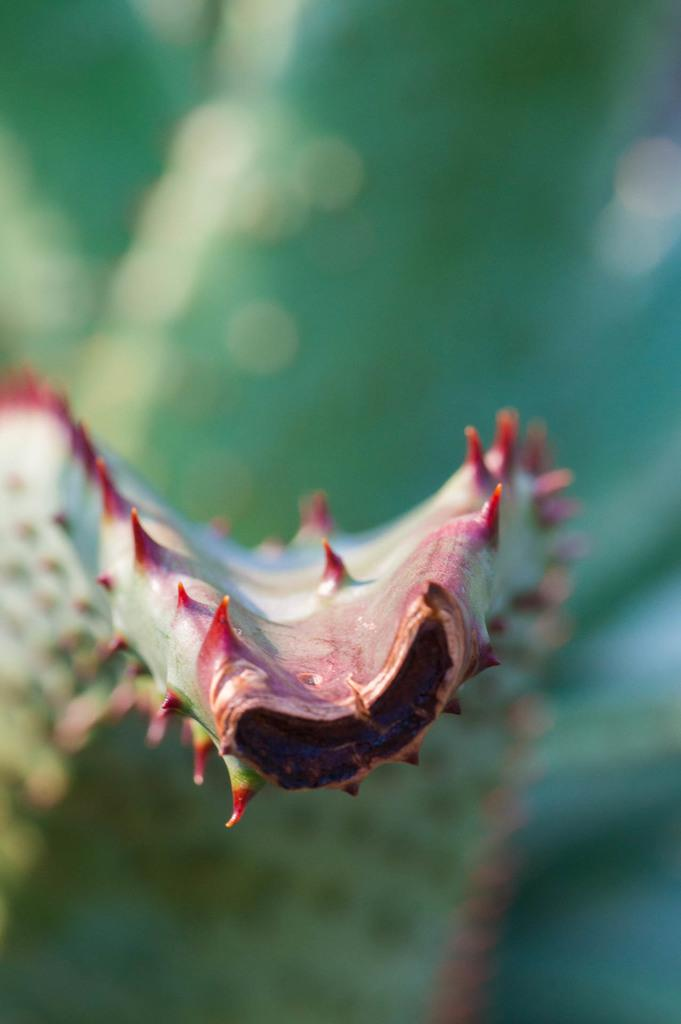What type of plant is in the picture? There is an aloe vera plant in the picture. Can you describe the background of the picture? The background of the picture is blurry. What type of yarn is being used to knit a sweater for the grandmother in the picture? There is no yarn, sweater, or grandmother present in the picture; it only features an aloe vera plant. 